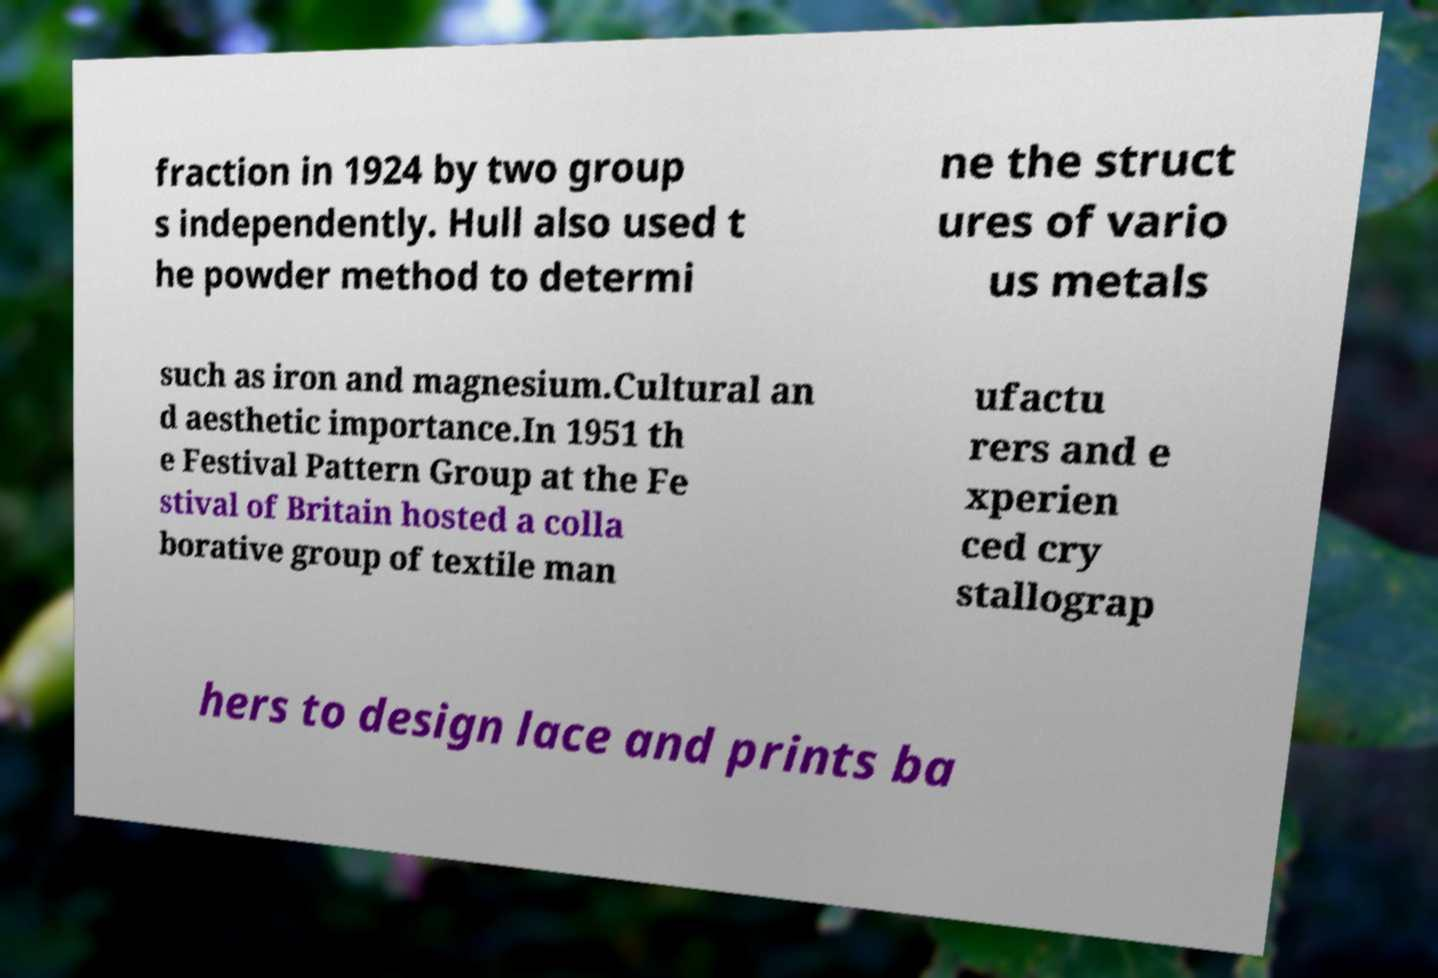What messages or text are displayed in this image? I need them in a readable, typed format. fraction in 1924 by two group s independently. Hull also used t he powder method to determi ne the struct ures of vario us metals such as iron and magnesium.Cultural an d aesthetic importance.In 1951 th e Festival Pattern Group at the Fe stival of Britain hosted a colla borative group of textile man ufactu rers and e xperien ced cry stallograp hers to design lace and prints ba 